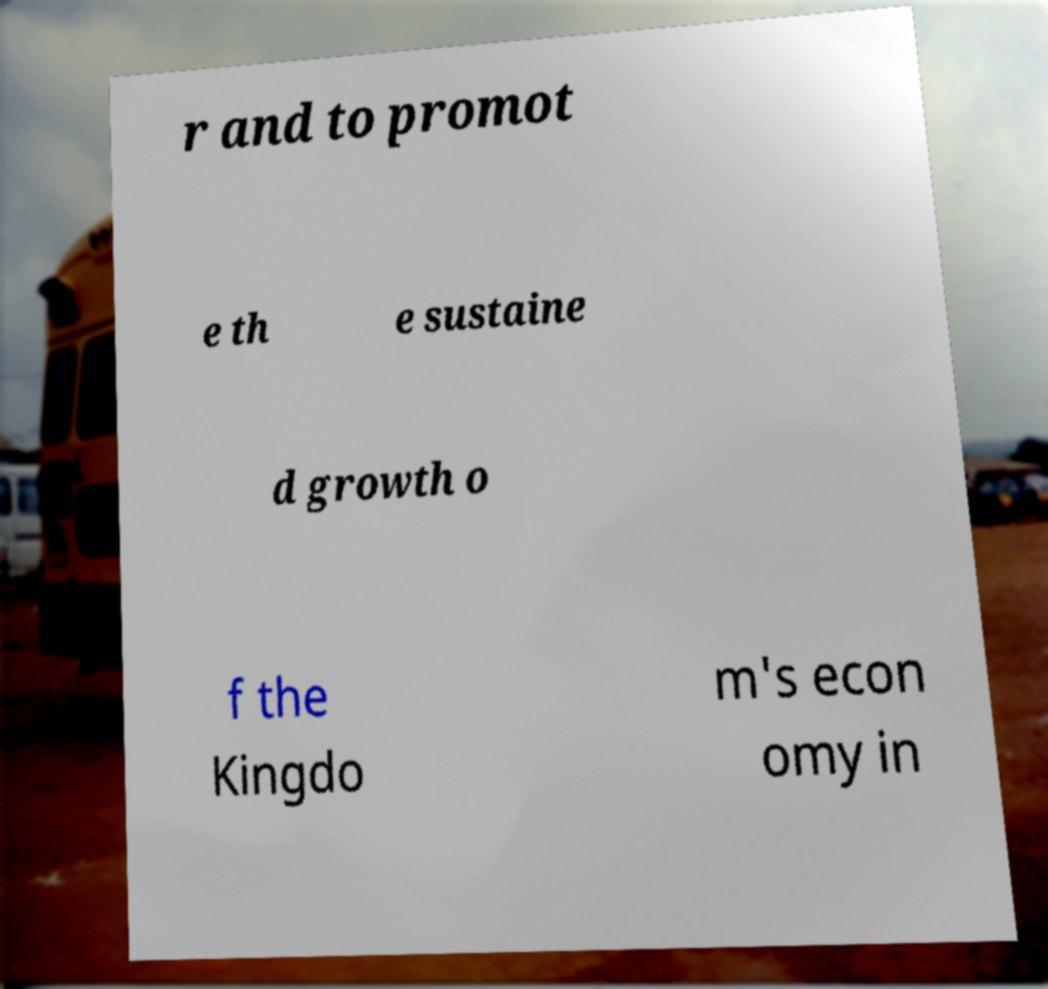Can you accurately transcribe the text from the provided image for me? r and to promot e th e sustaine d growth o f the Kingdo m's econ omy in 